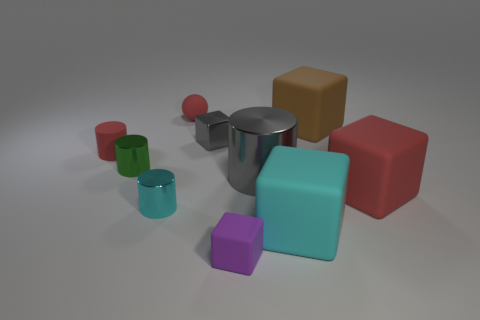Are there any other things that are the same size as the red cube?
Give a very brief answer. Yes. Does the large object to the left of the cyan cube have the same shape as the tiny green metal object?
Make the answer very short. Yes. How many gray metallic objects are right of the metallic block and behind the large gray metallic thing?
Make the answer very short. 0. The metal cylinder right of the tiny rubber thing right of the gray object that is behind the matte cylinder is what color?
Provide a succinct answer. Gray. There is a red cylinder to the left of the green shiny cylinder; what number of tiny green shiny things are to the left of it?
Your answer should be very brief. 0. What number of other things are there of the same shape as the big cyan object?
Offer a very short reply. 4. What number of things are tiny green objects or tiny matte objects in front of the brown block?
Your answer should be compact. 3. Are there more things in front of the small rubber cylinder than spheres that are left of the small cyan object?
Provide a succinct answer. Yes. There is a gray thing in front of the matte object that is left of the red rubber thing behind the small metal block; what shape is it?
Make the answer very short. Cylinder. What is the shape of the red matte thing that is on the right side of the tiny red matte thing that is right of the rubber cylinder?
Your answer should be compact. Cube. 